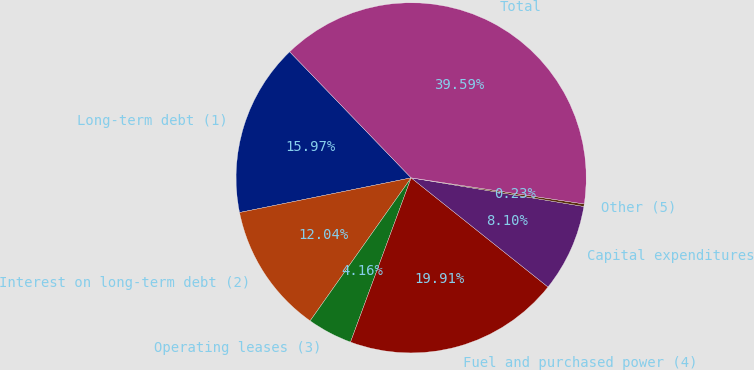Convert chart to OTSL. <chart><loc_0><loc_0><loc_500><loc_500><pie_chart><fcel>Long-term debt (1)<fcel>Interest on long-term debt (2)<fcel>Operating leases (3)<fcel>Fuel and purchased power (4)<fcel>Capital expenditures<fcel>Other (5)<fcel>Total<nl><fcel>15.97%<fcel>12.04%<fcel>4.16%<fcel>19.91%<fcel>8.1%<fcel>0.23%<fcel>39.59%<nl></chart> 